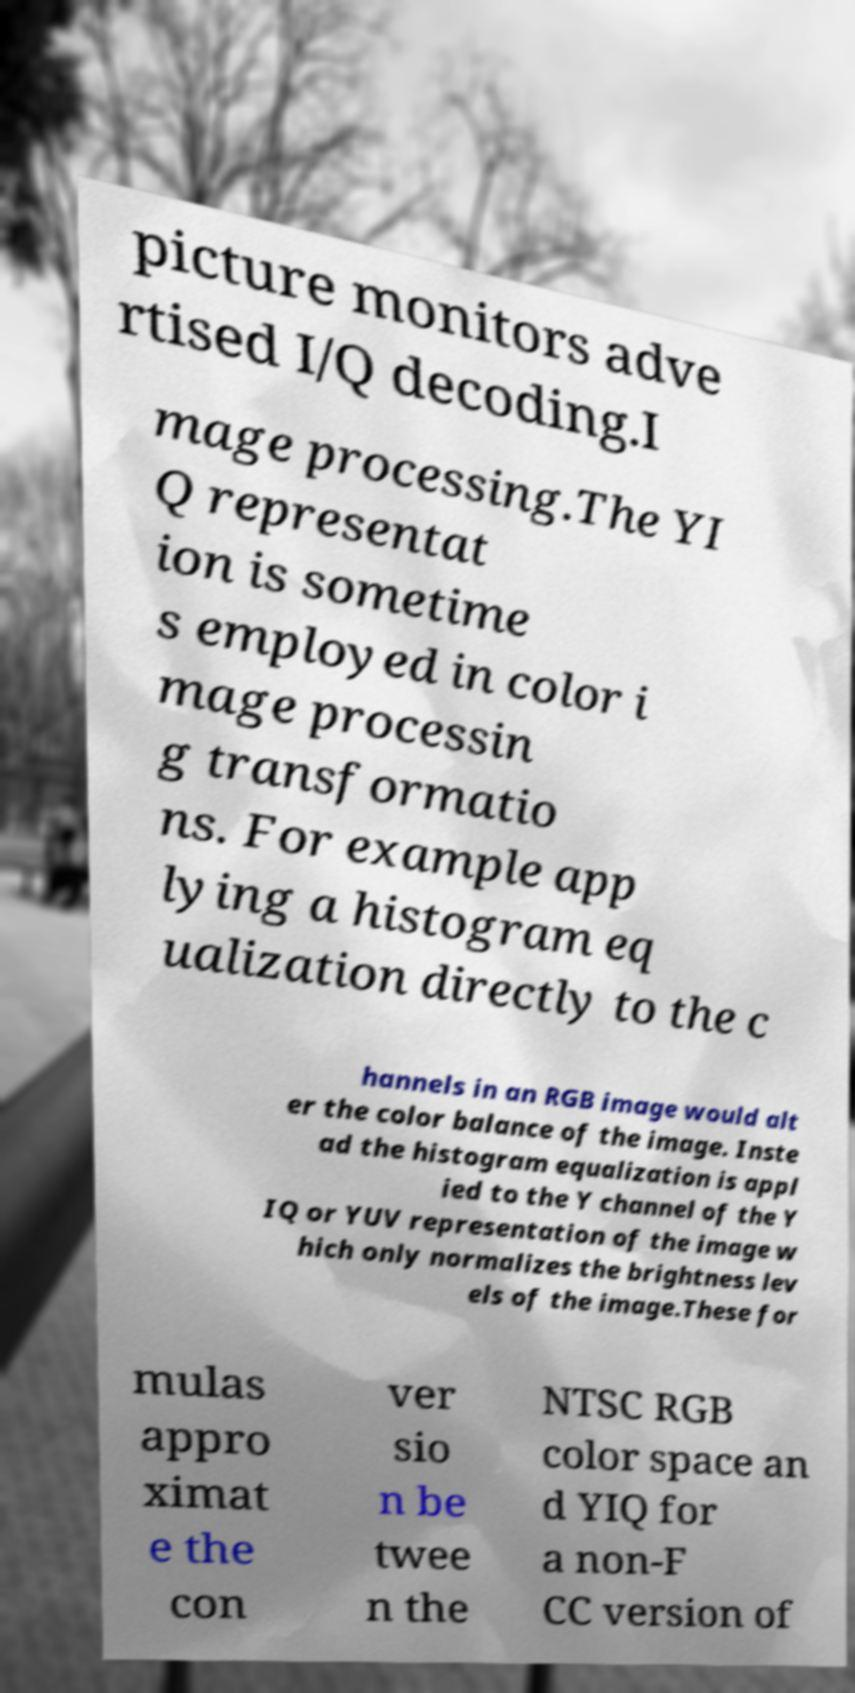Please read and relay the text visible in this image. What does it say? picture monitors adve rtised I/Q decoding.I mage processing.The YI Q representat ion is sometime s employed in color i mage processin g transformatio ns. For example app lying a histogram eq ualization directly to the c hannels in an RGB image would alt er the color balance of the image. Inste ad the histogram equalization is appl ied to the Y channel of the Y IQ or YUV representation of the image w hich only normalizes the brightness lev els of the image.These for mulas appro ximat e the con ver sio n be twee n the NTSC RGB color space an d YIQ for a non-F CC version of 